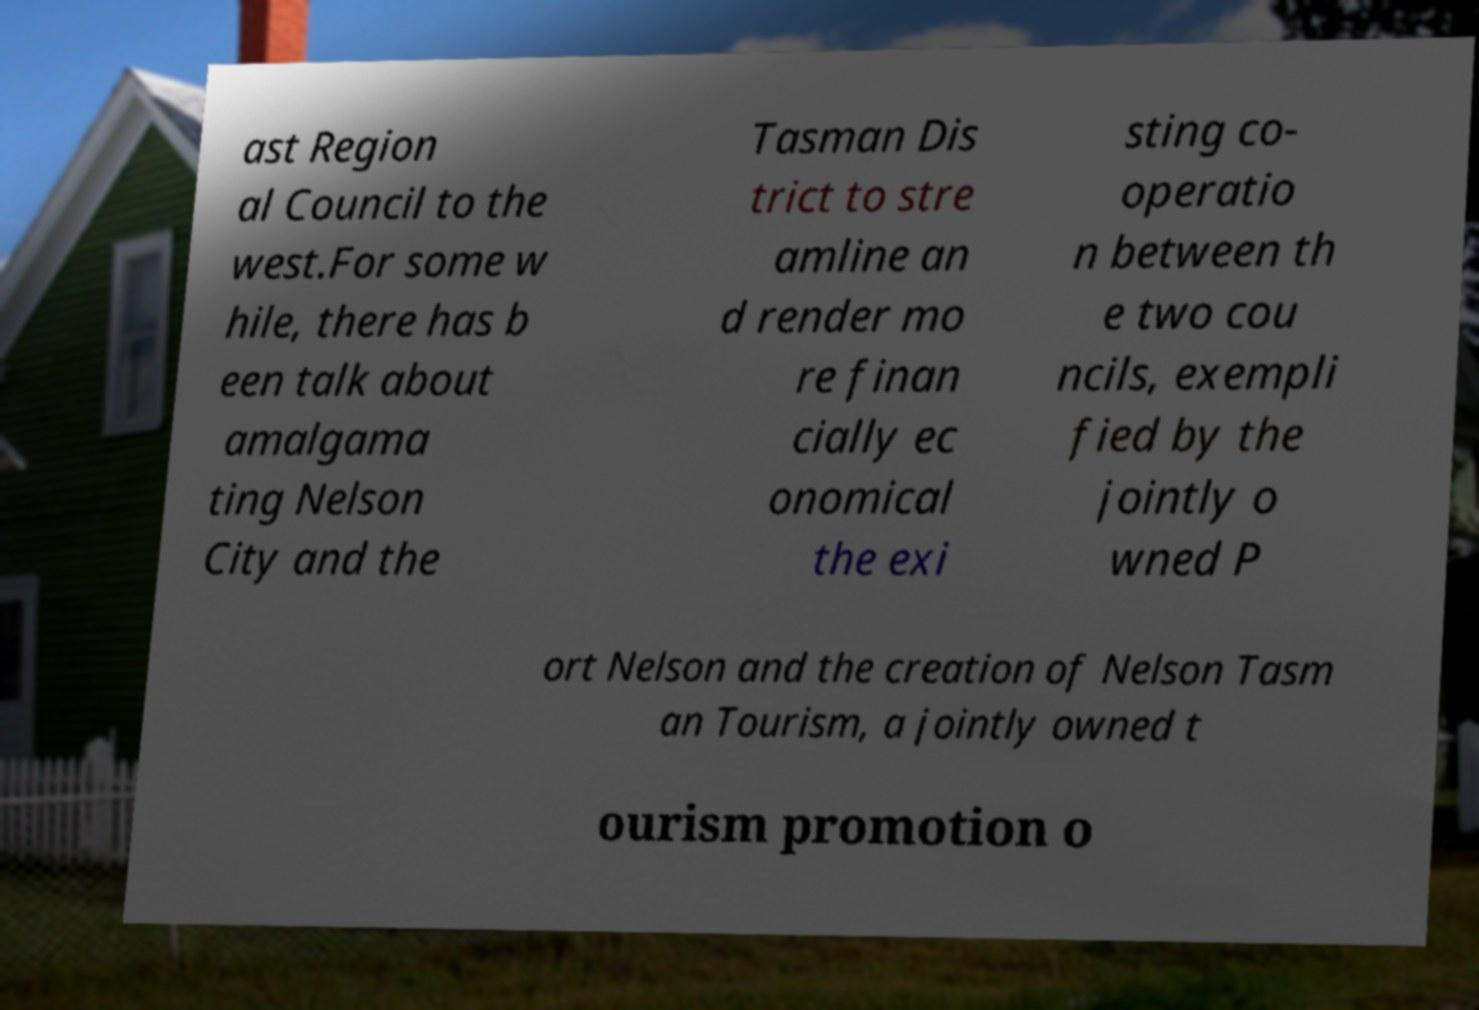I need the written content from this picture converted into text. Can you do that? ast Region al Council to the west.For some w hile, there has b een talk about amalgama ting Nelson City and the Tasman Dis trict to stre amline an d render mo re finan cially ec onomical the exi sting co- operatio n between th e two cou ncils, exempli fied by the jointly o wned P ort Nelson and the creation of Nelson Tasm an Tourism, a jointly owned t ourism promotion o 